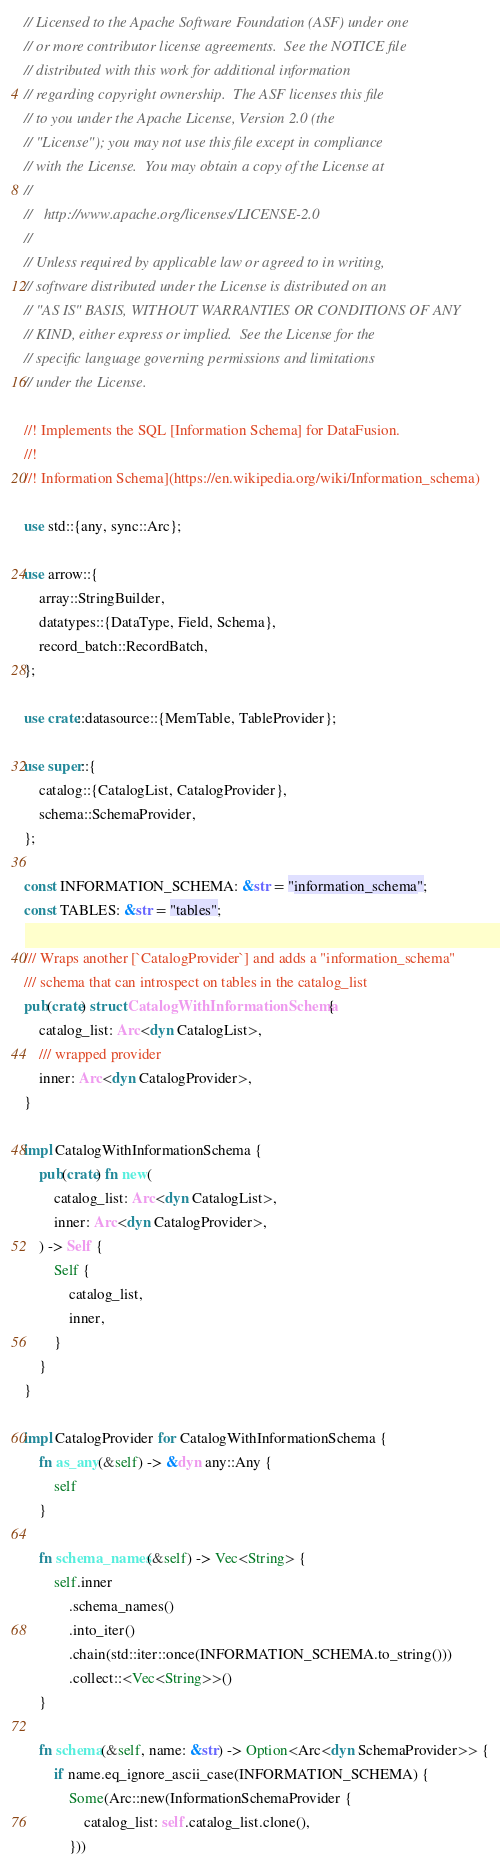<code> <loc_0><loc_0><loc_500><loc_500><_Rust_>// Licensed to the Apache Software Foundation (ASF) under one
// or more contributor license agreements.  See the NOTICE file
// distributed with this work for additional information
// regarding copyright ownership.  The ASF licenses this file
// to you under the Apache License, Version 2.0 (the
// "License"); you may not use this file except in compliance
// with the License.  You may obtain a copy of the License at
//
//   http://www.apache.org/licenses/LICENSE-2.0
//
// Unless required by applicable law or agreed to in writing,
// software distributed under the License is distributed on an
// "AS IS" BASIS, WITHOUT WARRANTIES OR CONDITIONS OF ANY
// KIND, either express or implied.  See the License for the
// specific language governing permissions and limitations
// under the License.

//! Implements the SQL [Information Schema] for DataFusion.
//!
//! Information Schema](https://en.wikipedia.org/wiki/Information_schema)

use std::{any, sync::Arc};

use arrow::{
    array::StringBuilder,
    datatypes::{DataType, Field, Schema},
    record_batch::RecordBatch,
};

use crate::datasource::{MemTable, TableProvider};

use super::{
    catalog::{CatalogList, CatalogProvider},
    schema::SchemaProvider,
};

const INFORMATION_SCHEMA: &str = "information_schema";
const TABLES: &str = "tables";

/// Wraps another [`CatalogProvider`] and adds a "information_schema"
/// schema that can introspect on tables in the catalog_list
pub(crate) struct CatalogWithInformationSchema {
    catalog_list: Arc<dyn CatalogList>,
    /// wrapped provider
    inner: Arc<dyn CatalogProvider>,
}

impl CatalogWithInformationSchema {
    pub(crate) fn new(
        catalog_list: Arc<dyn CatalogList>,
        inner: Arc<dyn CatalogProvider>,
    ) -> Self {
        Self {
            catalog_list,
            inner,
        }
    }
}

impl CatalogProvider for CatalogWithInformationSchema {
    fn as_any(&self) -> &dyn any::Any {
        self
    }

    fn schema_names(&self) -> Vec<String> {
        self.inner
            .schema_names()
            .into_iter()
            .chain(std::iter::once(INFORMATION_SCHEMA.to_string()))
            .collect::<Vec<String>>()
    }

    fn schema(&self, name: &str) -> Option<Arc<dyn SchemaProvider>> {
        if name.eq_ignore_ascii_case(INFORMATION_SCHEMA) {
            Some(Arc::new(InformationSchemaProvider {
                catalog_list: self.catalog_list.clone(),
            }))</code> 